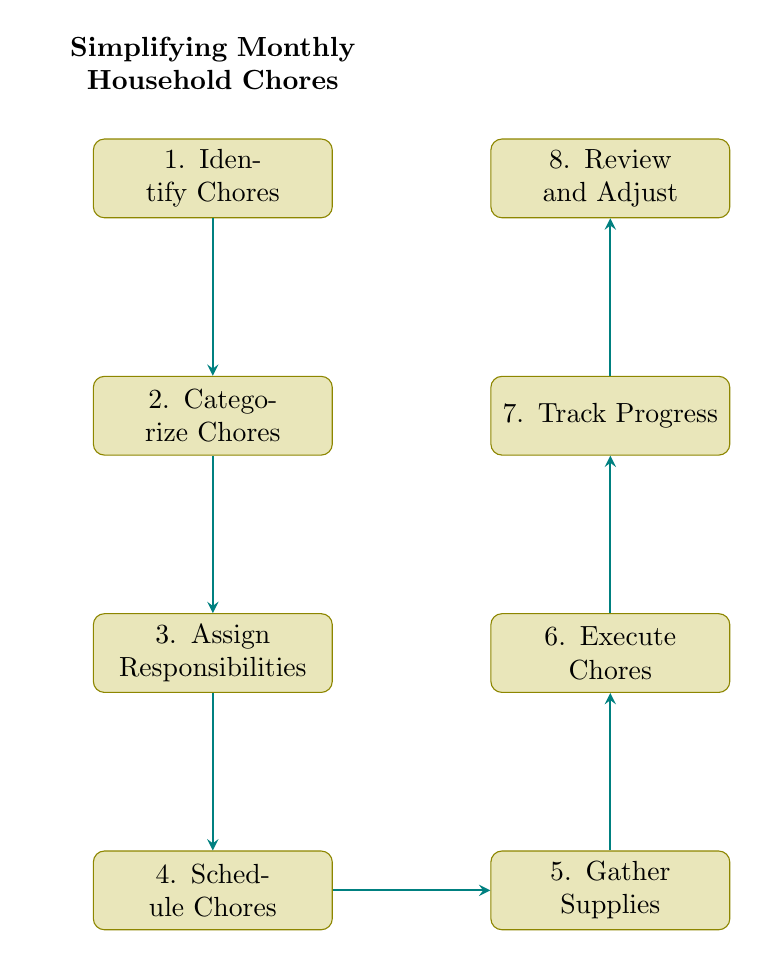What is the first step in the flow chart? The first step in the flow chart is labeled "Identify Chores." This is the starting point indicated at the top of the diagram.
Answer: Identify Chores How many total nodes are present in the diagram? The diagram displays a total of eight nodes, each representing a different step in the process of simplifying household chores.
Answer: 8 What is the last step in the process? The last step is represented by the node labeled "Review and Adjust." It is found at the topmost position in the flow order, following the completion of the prior steps.
Answer: Review and Adjust How does one proceed after "Execute Chores"? After "Execute Chores," the next step involves "Track Progress." This conveys that tracking follows after executing the chores to ensure all tasks are monitored.
Answer: Track Progress What type of tasks is associated with node 5? Node 5, labeled "Gather Supplies," is associated with the task of collecting all necessary cleaning supplies and tools for the chores.
Answer: Gather Supplies What links "Categorize Chores" to "Assign Responsibilities"? The connection from "Categorize Chores" to "Assign Responsibilities" indicates the flow of the process, where after categorization, the next logical step is to assign specific chores to individuals.
Answer: Assign Responsibilities Which node involves the use of a planner or calendar? The node labeled "Schedule Chores" specifically involves using a planner or digital calendar to organize and arrange the chores for completion.
Answer: Schedule Chores What happens if one skips the "Gather Supplies" step? Skipping the "Gather Supplies" step (node 5) could hinder the ability to successfully "Execute Chores" because the necessary tools and cleaning supplies won't be ready, potentially stopping progress.
Answer: Execute Chores How many connections are shown in the flow chart? The flow chart has a total of seven connections, which illustrate the directional flow from one process step to the next in the chore management system.
Answer: 7 